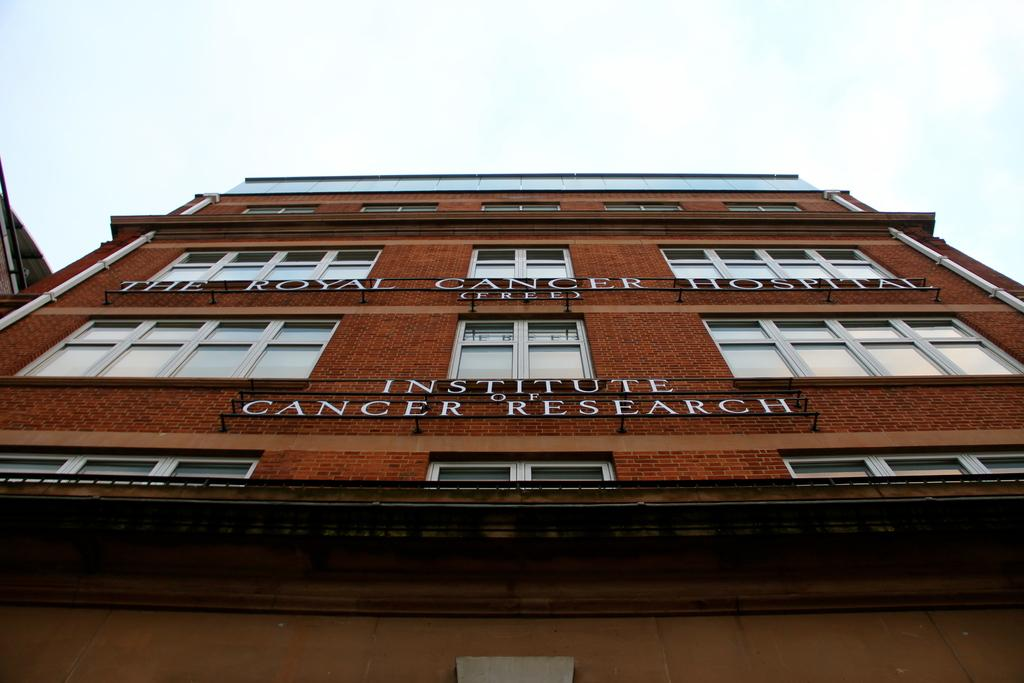What is the main subject in the center of the image? There is a building in the center of the image. What can be seen at the top of the image? The sky is visible at the top of the image. How many screws can be seen on the wall in the image? There is no wall or screws present in the image; it only features a building and the sky. 